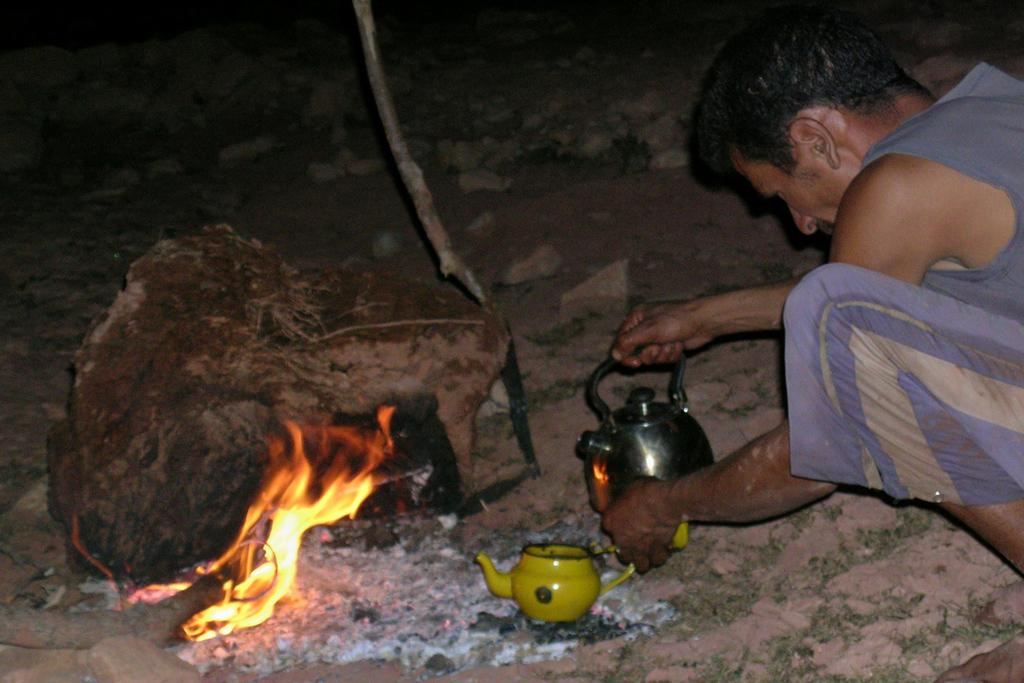Who or what is present in the image? There is a person in the image. What is the person holding? The person is holding a thermos. What can be seen in the background of the image? There is a fire in the image. What is on the ground in the image? There are stones on the ground in the image. How close is the person to the stones? The person is near the stones. What type of letter is the person writing on the ground in the image? There is no letter present in the image, and the person is not writing on the ground. 